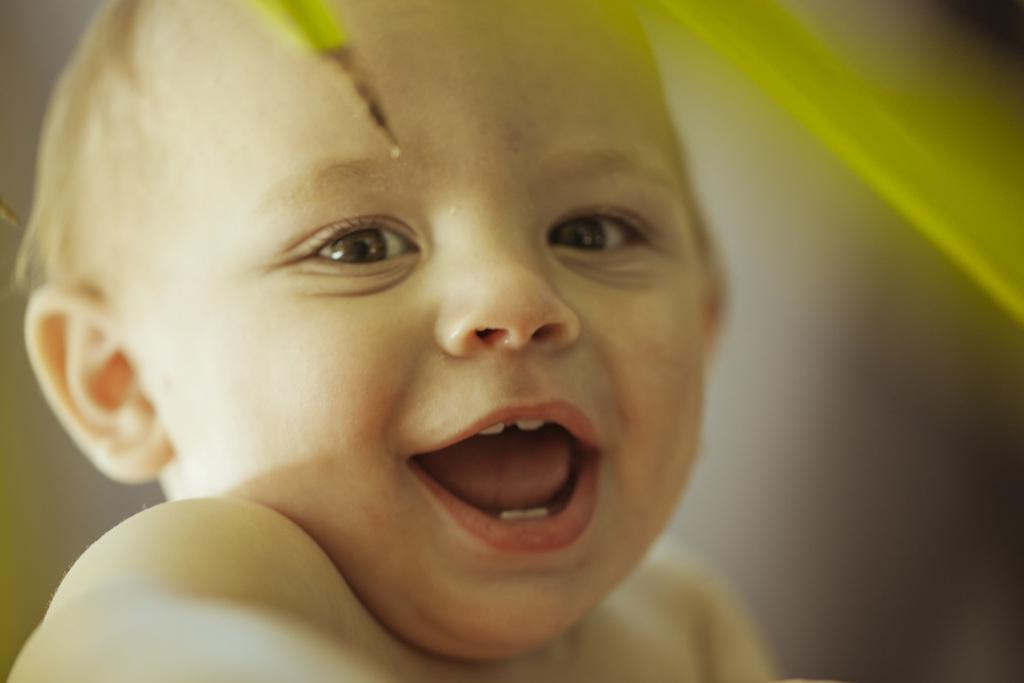What is the main subject of the image? The main subject of the image is a child. What can be seen in the background of the image? There are leaves visible in the background of the image. How many tomatoes can be seen on the child's feet in the image? There are no tomatoes visible on the child's feet in the image. What type of event is taking place in the image? There is no indication of any specific event taking place in the image. 